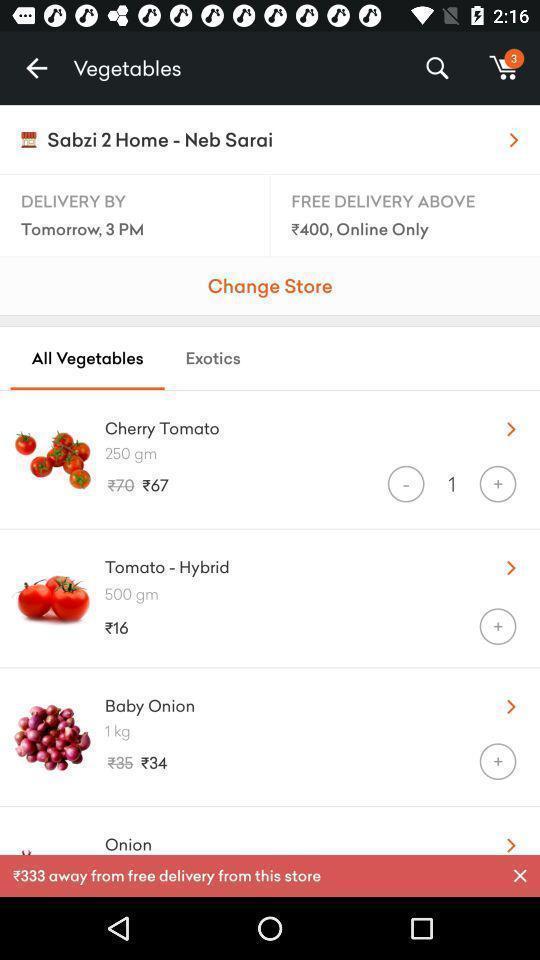Tell me what you see in this picture. Screen showing all vegetables. 